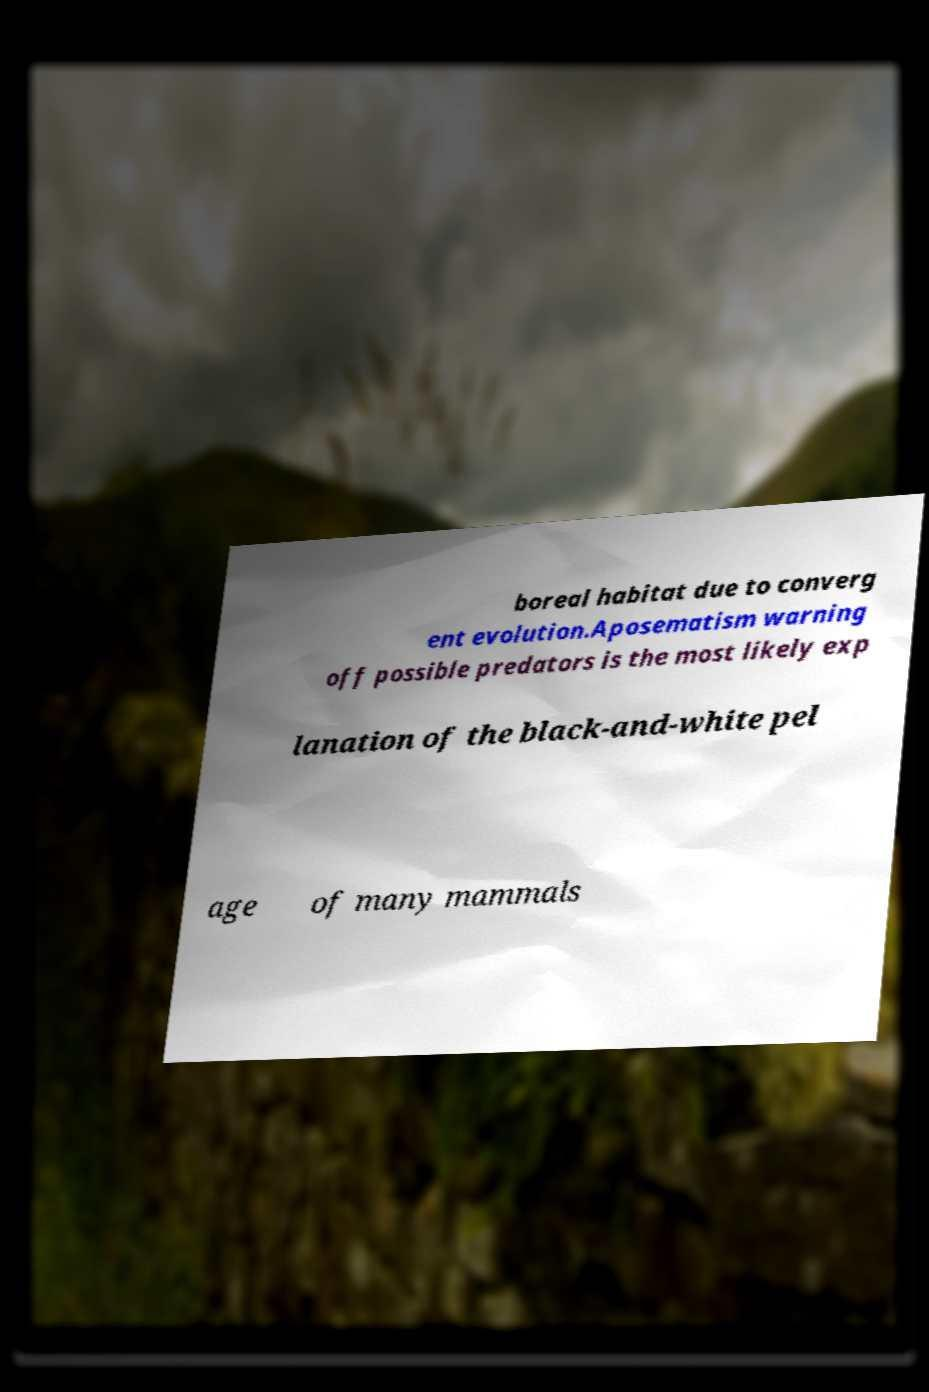For documentation purposes, I need the text within this image transcribed. Could you provide that? boreal habitat due to converg ent evolution.Aposematism warning off possible predators is the most likely exp lanation of the black-and-white pel age of many mammals 